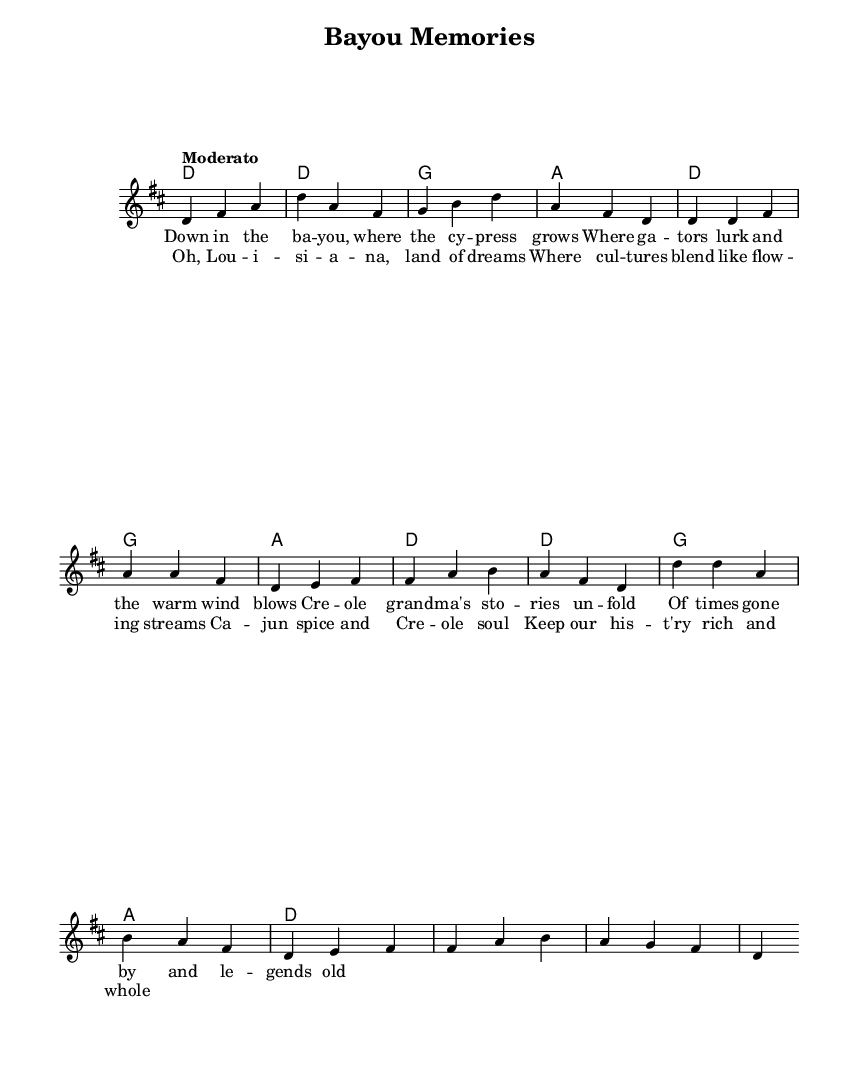What is the key signature of this music? The key signature is indicated by the presence of two sharps (F# and C#) in the associated scale, which is D major.
Answer: D major What is the time signature of this music? The time signature is represented by the fraction at the beginning of the score, indicating three beats per measure, which is noted as 3/4.
Answer: 3/4 What is the tempo marking of this piece? The tempo marking "Moderato" is placed in the score, indicating a moderate speed for the performance of the piece.
Answer: Moderato How many measures are in the chorus section? By counting the measures of the music notated for the chorus, which consists of four lines, each with four measures, the total number is eight.
Answer: Eight What type of musical form is primarily used in this piece? This piece adopts a verse-chorus structure, which is evident from the alternation between the verse and the chorus sections in the lyrics.
Answer: Verse-chorus What cultural themes are present in the lyrics of this piece? The lyrics narrate stories related to Creole and Cajun cultures, mentioning elements such as Cajun spice and the blending of cultures in Louisiana.
Answer: Cajun and Creole cultures What instrument is primarily used to play the melody in this score? The composition does not specify an instrument, but the notation is written for a staff commonly used for instruments like the piano or flute.
Answer: Voice (or typical piano) 